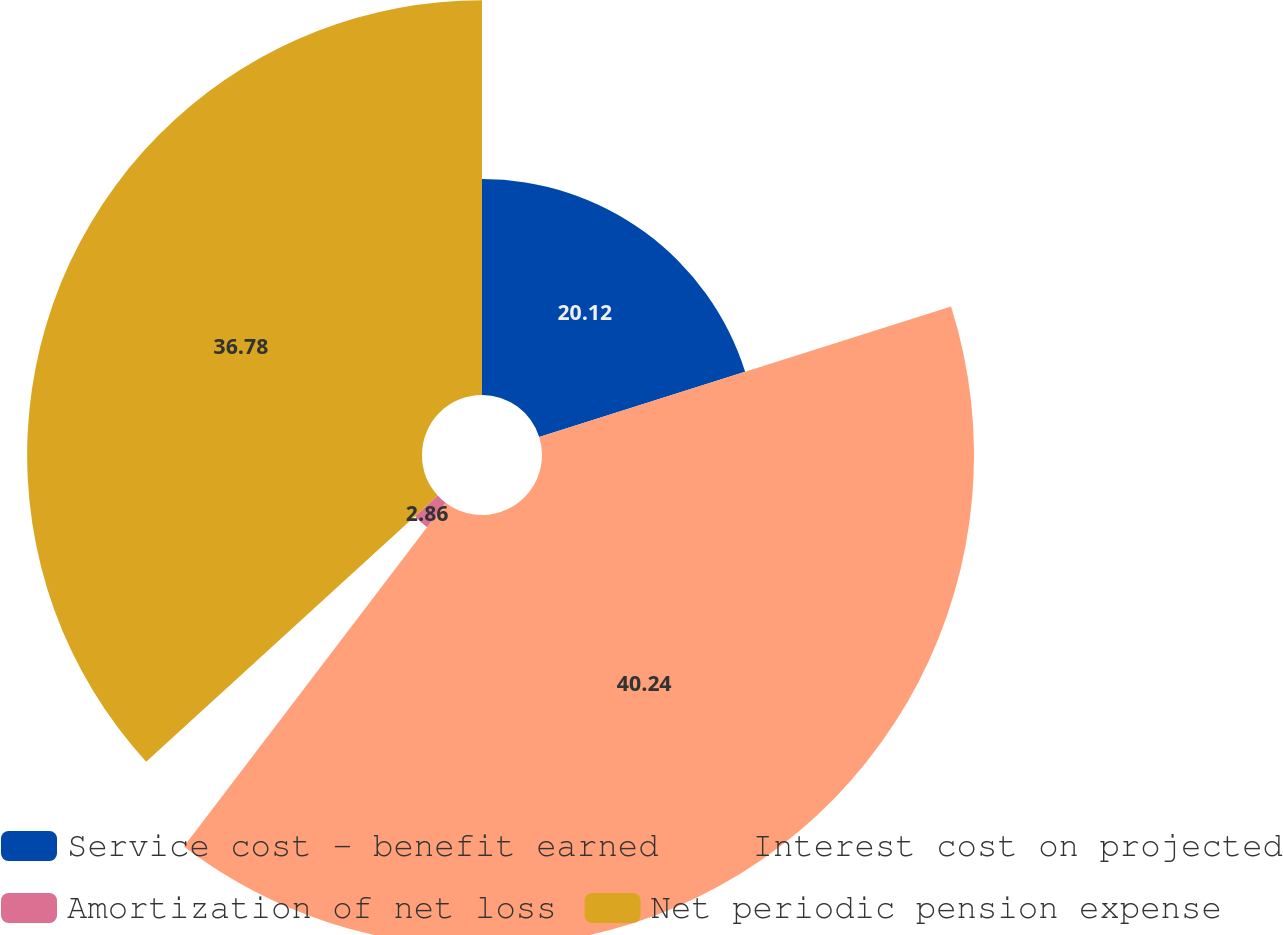Convert chart to OTSL. <chart><loc_0><loc_0><loc_500><loc_500><pie_chart><fcel>Service cost - benefit earned<fcel>Interest cost on projected<fcel>Amortization of net loss<fcel>Net periodic pension expense<nl><fcel>20.12%<fcel>40.24%<fcel>2.86%<fcel>36.78%<nl></chart> 